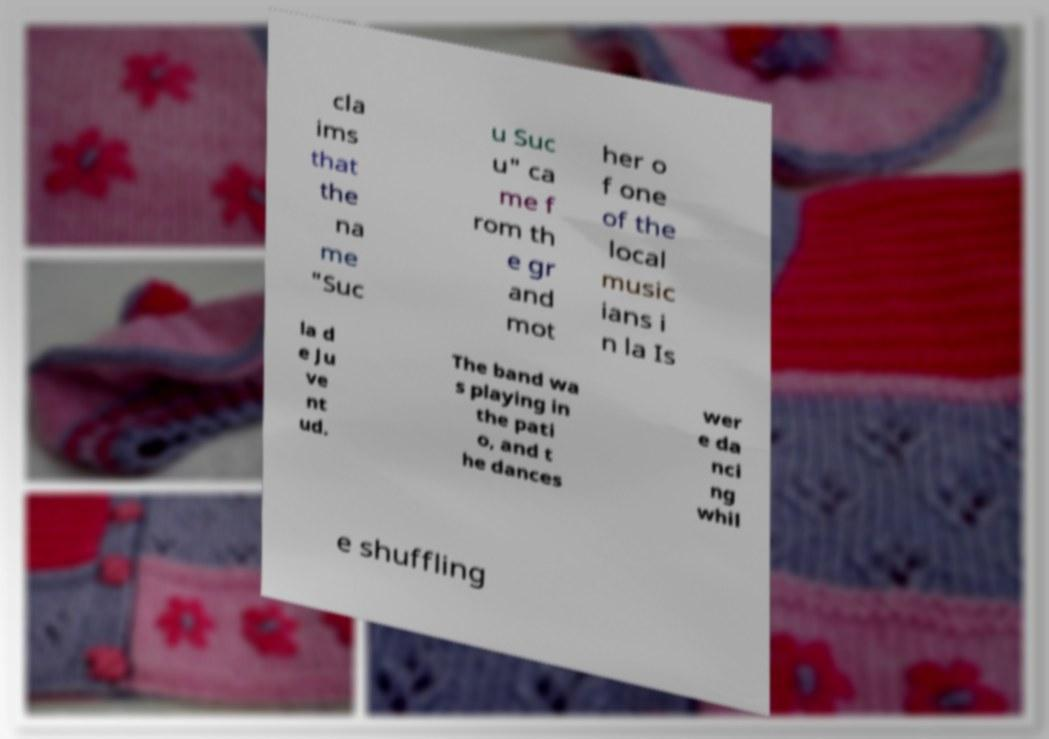For documentation purposes, I need the text within this image transcribed. Could you provide that? cla ims that the na me "Suc u Suc u" ca me f rom th e gr and mot her o f one of the local music ians i n la Is la d e Ju ve nt ud. The band wa s playing in the pati o, and t he dances wer e da nci ng whil e shuffling 